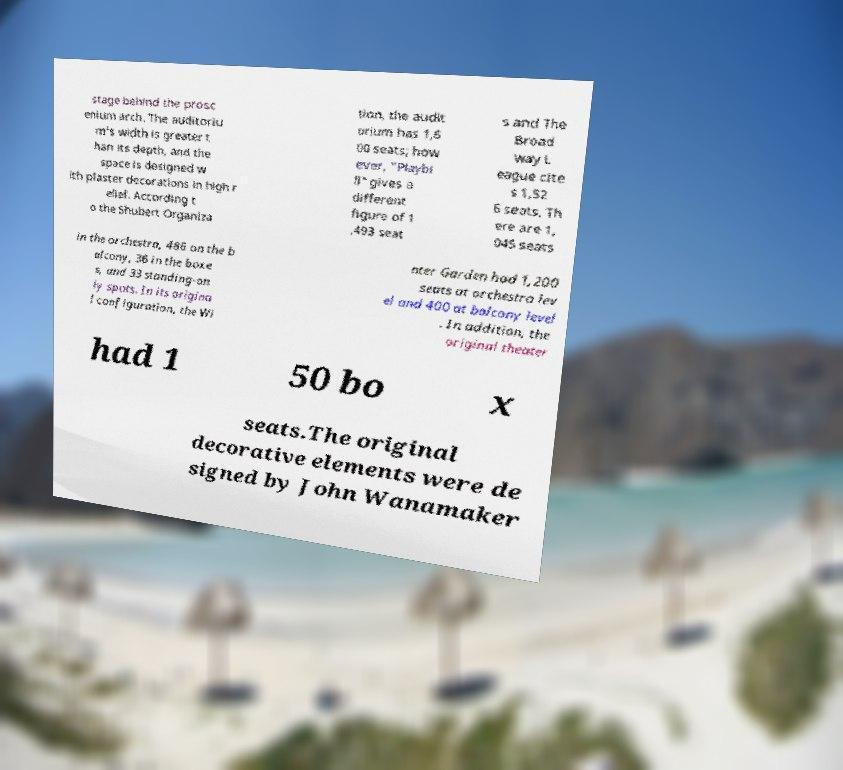There's text embedded in this image that I need extracted. Can you transcribe it verbatim? stage behind the prosc enium arch. The auditoriu m's width is greater t han its depth, and the space is designed w ith plaster decorations in high r elief. According t o the Shubert Organiza tion, the audit orium has 1,6 00 seats; how ever, "Playbi ll" gives a different figure of 1 ,493 seat s and The Broad way L eague cite s 1,52 6 seats. Th ere are 1, 045 seats in the orchestra, 486 on the b alcony, 36 in the boxe s, and 33 standing-on ly spots. In its origina l configuration, the Wi nter Garden had 1,200 seats at orchestra lev el and 400 at balcony level . In addition, the original theater had 1 50 bo x seats.The original decorative elements were de signed by John Wanamaker 